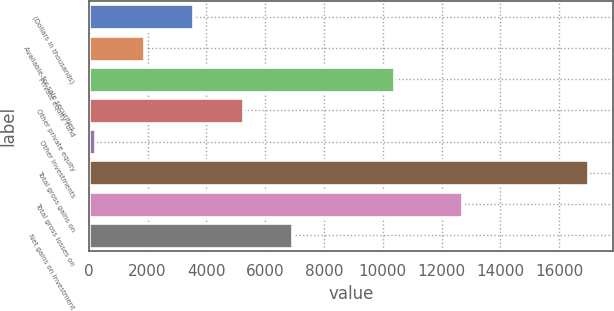<chart> <loc_0><loc_0><loc_500><loc_500><bar_chart><fcel>(Dollars in thousands)<fcel>Available-for-sale securities<fcel>Private equity fund<fcel>Other private equity<fcel>Other investments<fcel>Total gross gains on<fcel>Total gross losses on<fcel>Net gains on investment<nl><fcel>3558<fcel>1878.5<fcel>10375<fcel>5237.5<fcel>199<fcel>16994<fcel>12687<fcel>6917<nl></chart> 